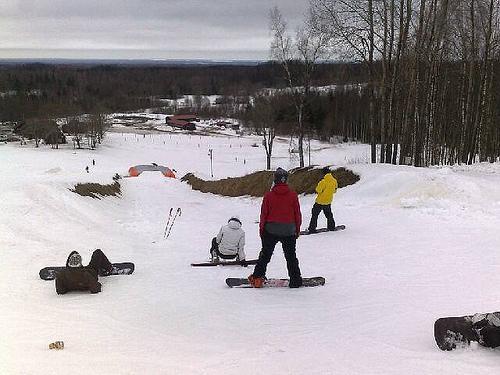How many snowboards are seen?
Give a very brief answer. 5. How many people are not standing?
Give a very brief answer. 2. How many snowboards are shown here?
Give a very brief answer. 5. How many cats have a banana in their paws?
Give a very brief answer. 0. 